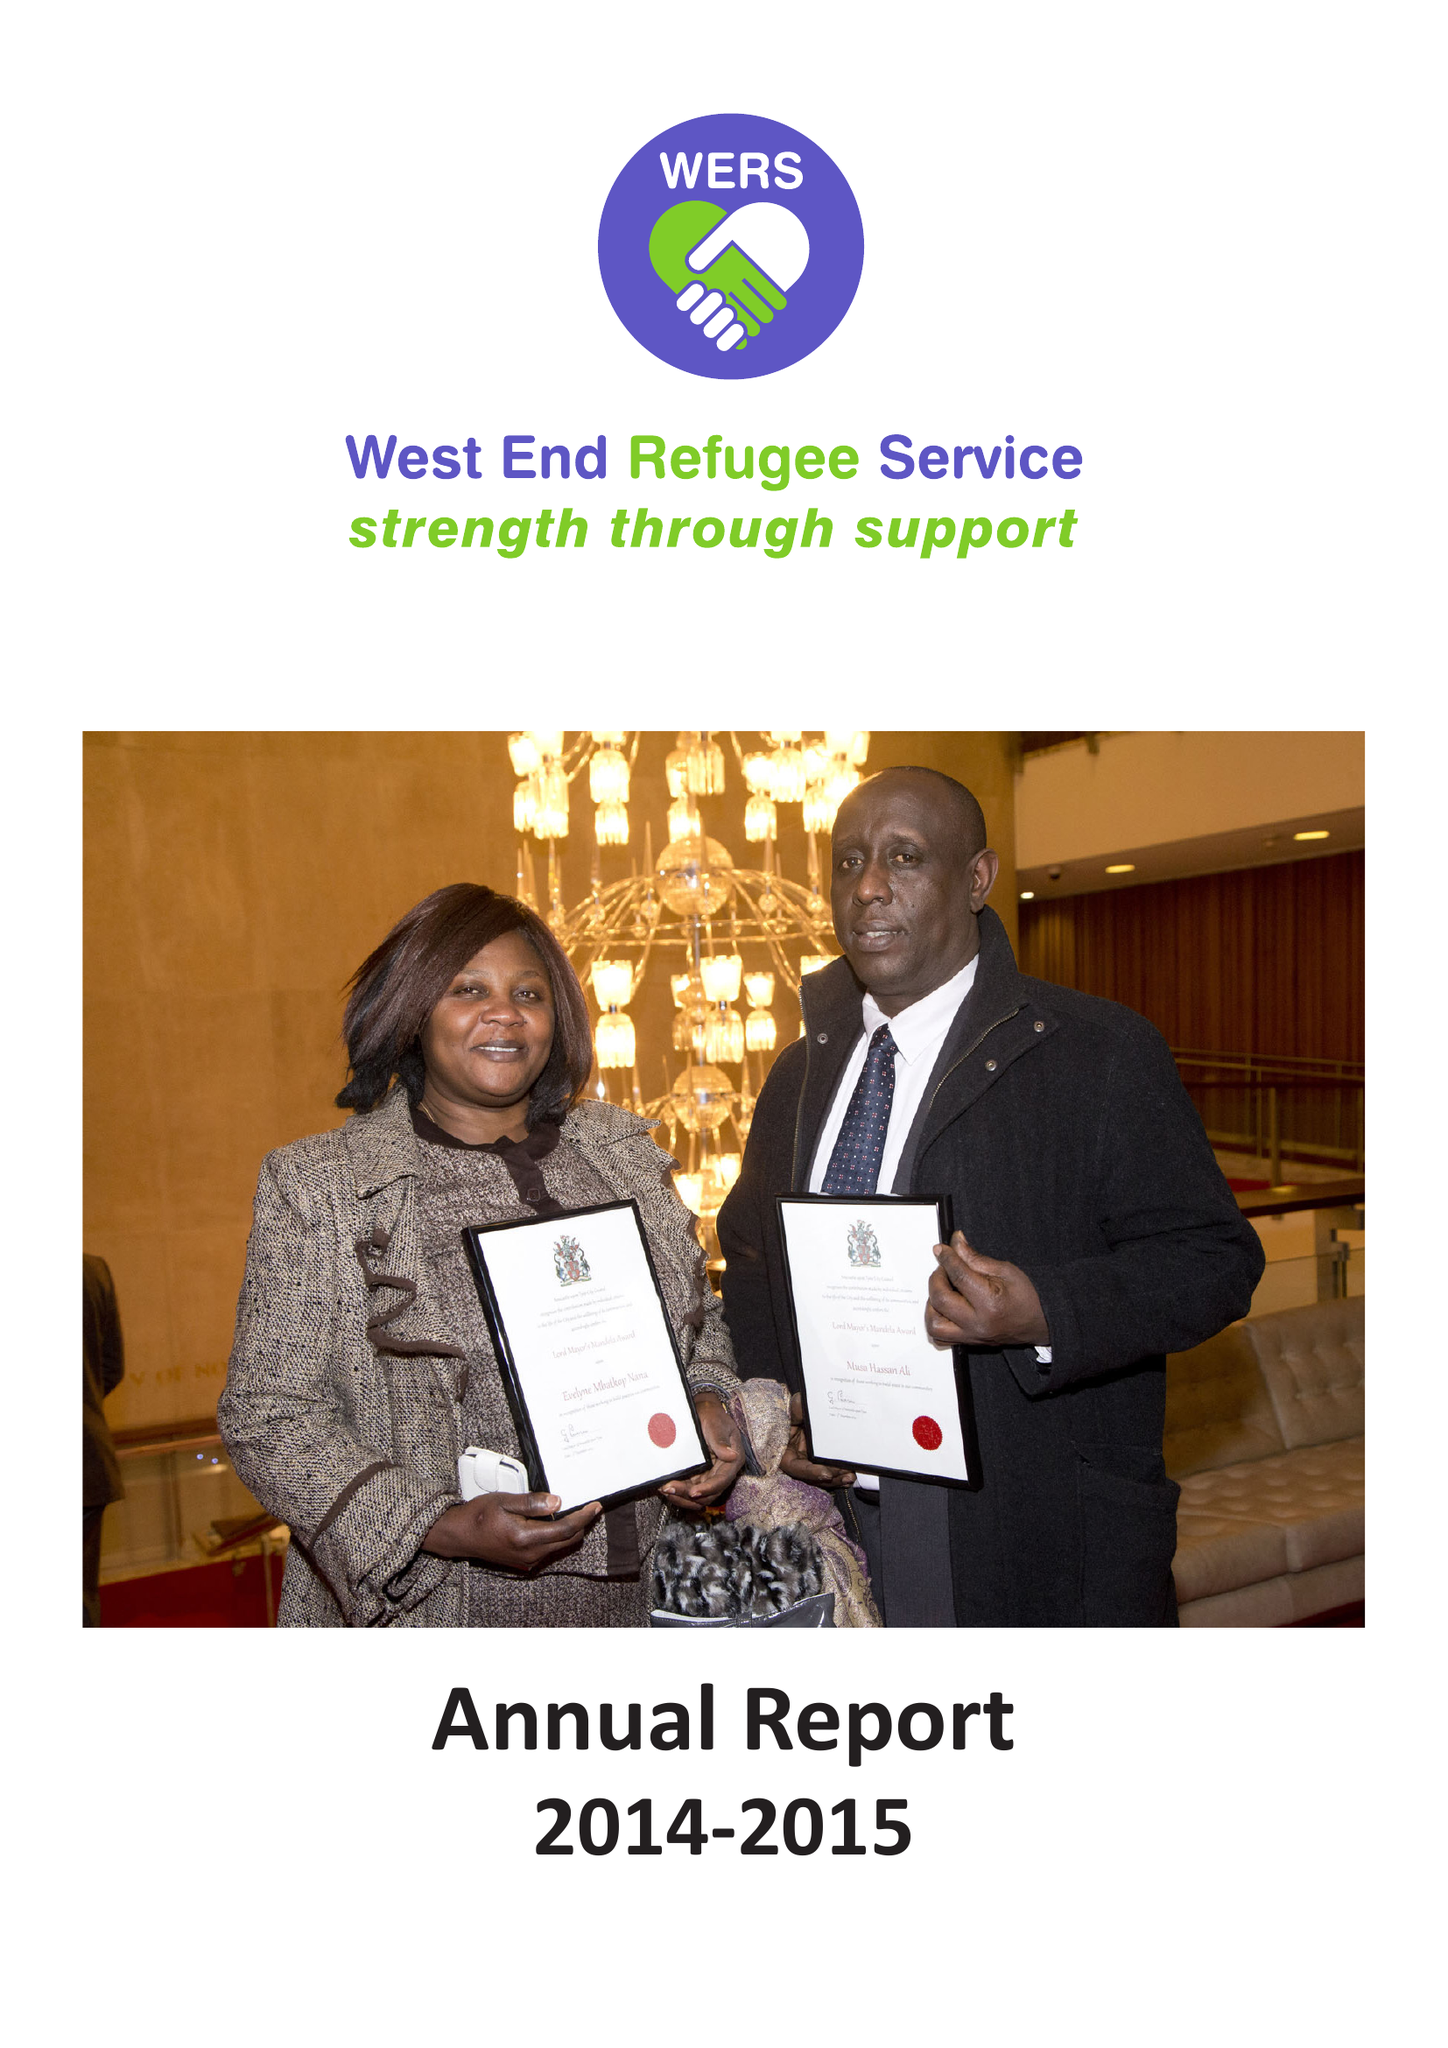What is the value for the spending_annually_in_british_pounds?
Answer the question using a single word or phrase. 256704.00 